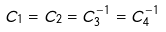<formula> <loc_0><loc_0><loc_500><loc_500>C _ { 1 } = C _ { 2 } = C _ { 3 } ^ { - 1 } = C _ { 4 } ^ { - 1 }</formula> 